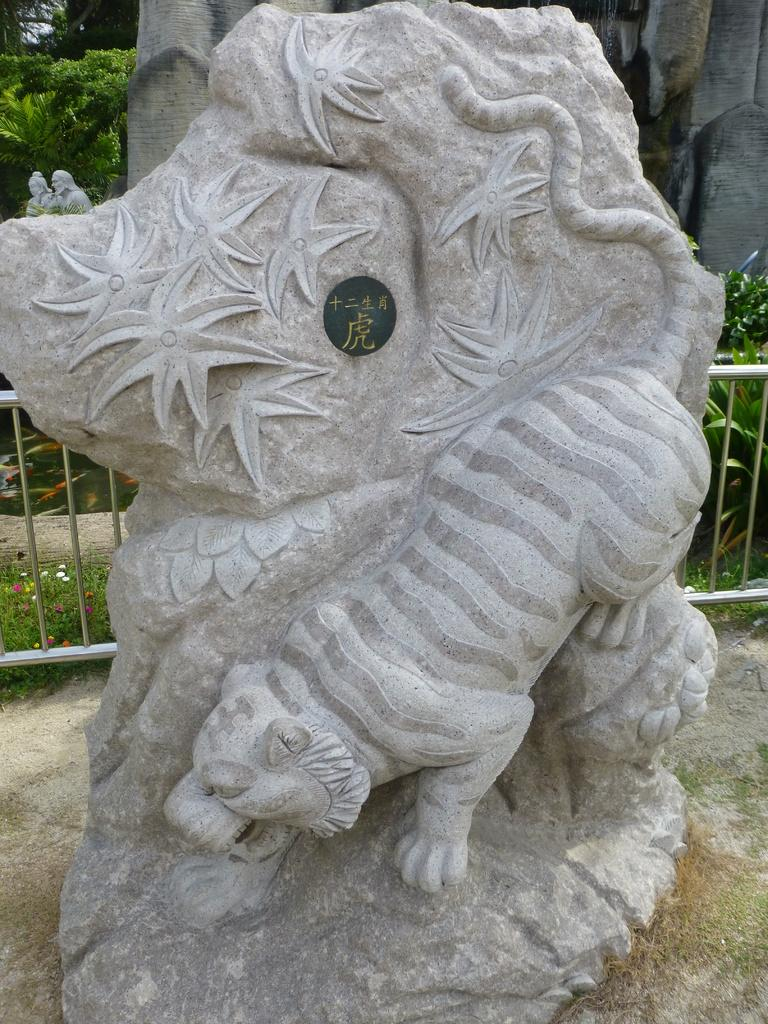What is the main subject of the image? There is a statue of an animal in the image. What is located behind the statue? There is a fence behind the statue. What type of vegetation can be seen in the image? There are plants with flowers and trees in the image. Can you describe the object in the image? Unfortunately, the facts provided do not specify the type of object in the image. What role does the actor play in the image? There is no actor present in the image; it features a statue of an animal. Can you tell me how many donkeys are depicted in the image? There is no donkey present in the image; the statue is of an unspecified animal. 